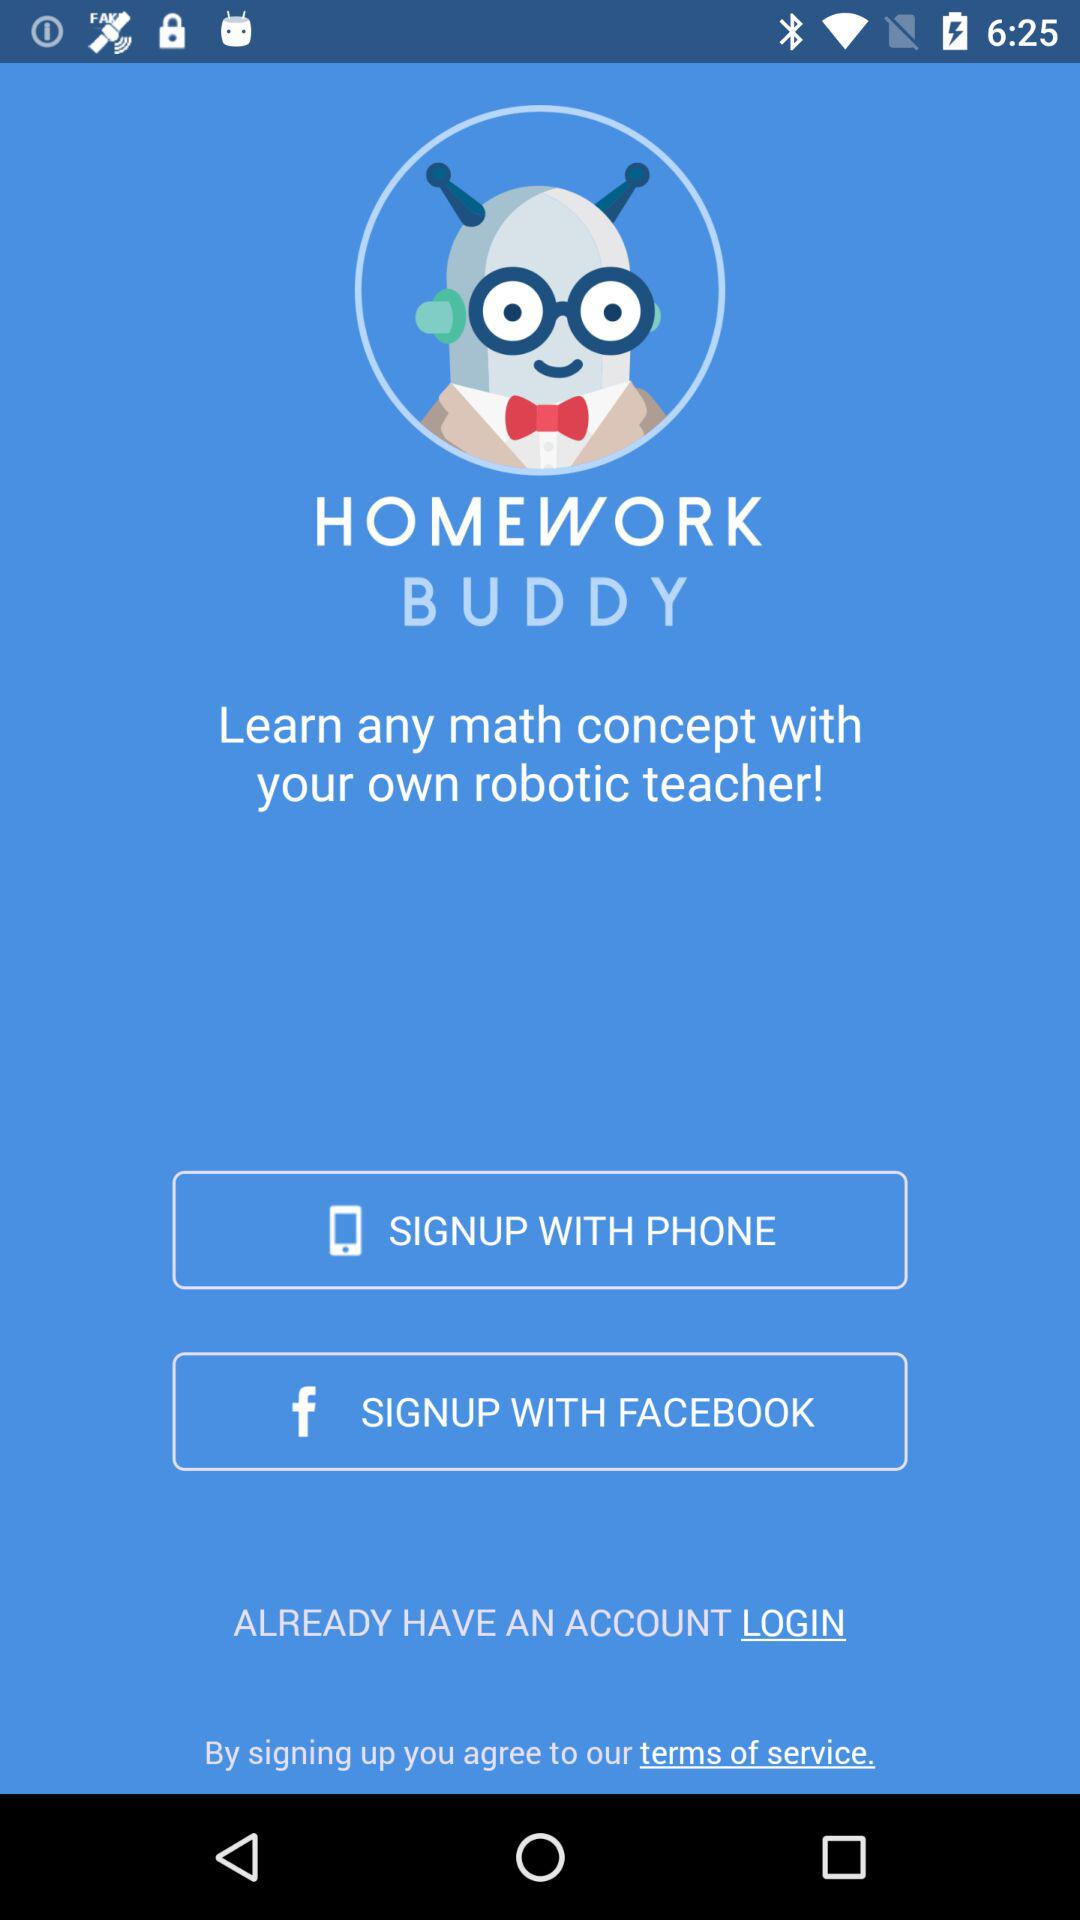Who is signing up?
When the provided information is insufficient, respond with <no answer>. <no answer> 